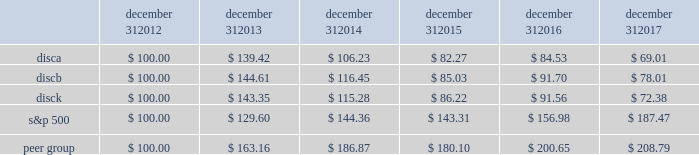Part ii item 5 .
Market for registrant 2019s common equity , related stockholder matters and issuer purchases of equity securities .
Our series a common stock , series b common stock and series c common stock are listed and traded on the nasdaq global select market ( 201cnasdaq 201d ) under the symbols 201cdisca , 201d 201cdiscb 201d and 201cdisck , 201d respectively .
The table sets forth , for the periods indicated , the range of high and low sales prices per share of our series a common stock , series b common stock and series c common stock as reported on yahoo! finance ( finance.yahoo.com ) .
Series a common stock series b common stock series c common stock high low high low high low fourth quarter $ 23.73 $ 16.28 $ 26.80 $ 20.00 $ 22.47 $ 15.27 third quarter $ 27.18 $ 20.80 $ 27.90 $ 22.00 $ 26.21 $ 19.62 second quarter $ 29.40 $ 25.11 $ 29.55 $ 25.45 $ 28.90 $ 24.39 first quarter $ 29.62 $ 26.34 $ 29.65 $ 27.55 $ 28.87 $ 25.76 fourth quarter $ 29.55 $ 25.01 $ 30.50 $ 26.00 $ 28.66 $ 24.20 third quarter $ 26.97 $ 24.27 $ 28.00 $ 25.21 $ 26.31 $ 23.44 second quarter $ 29.31 $ 23.73 $ 29.34 $ 24.15 $ 28.48 $ 22.54 first quarter $ 29.42 $ 24.33 $ 29.34 $ 24.30 $ 28.00 $ 23.81 as of february 21 , 2018 , there were approximately 1308 , 75 and 1414 record holders of our series a common stock , series b common stock and series c common stock , respectively .
These amounts do not include the number of shareholders whose shares are held of record by banks , brokerage houses or other institutions , but include each such institution as one shareholder .
We have not paid any cash dividends on our series a common stock , series b common stock or series c common stock , and we have no present intention to do so .
Payment of cash dividends , if any , will be determined by our board of directors after consideration of our earnings , financial condition and other relevant factors such as our credit facility's restrictions on our ability to declare dividends in certain situations .
Purchases of equity securities the table presents information about our repurchases of common stock that were made through open market transactions during the three months ended december 31 , 2017 ( in millions , except per share amounts ) .
Period total number of series c shares purchased average paid per share : series c ( a ) total number of shares purchased as part of publicly announced plans or programs ( b ) ( c ) approximate dollar value of shares that may yet be purchased under the plans or programs ( a ) ( b ) october 1 , 2017 - october 31 , 2017 2014 $ 2014 2014 $ 2014 november 1 , 2017 - november 30 , 2017 2014 $ 2014 2014 $ 2014 december 1 , 2017 - december 31 , 2017 2014 $ 2014 2014 $ 2014 total 2014 2014 $ 2014 ( a ) the amounts do not give effect to any fees , commissions or other costs associated with repurchases of shares .
( b ) under the stock repurchase program , management was authorized to purchase shares of the company's common stock from time to time through open market purchases or privately negotiated transactions at prevailing prices or pursuant to one or more accelerated stock repurchase agreements or other derivative arrangements as permitted by securities laws and other legal requirements , and subject to stock price , business and market conditions and other factors .
The company's authorization under the program expired on october 8 , 2017 and we have not repurchased any shares of common stock since then .
We historically have funded and in the future may fund stock repurchases through a combination of cash on hand and cash generated by operations and the issuance of debt .
In the future , if further authorization is provided , we may also choose to fund stock repurchases through borrowings under our revolving credit facility or future financing transactions .
There were no repurchases of our series a and b common stock during 2017 and no repurchases of series c common stock during the three months ended december 31 , 2017 .
The company first announced its stock repurchase program on august 3 , 2010 .
( c ) we entered into an agreement with advance/newhouse to repurchase , on a quarterly basis , a number of shares of series c-1 convertible preferred stock convertible into a number of shares of series c common stock .
We did not convert any any shares of series c-1 convertible preferred stock during the three months ended december 31 , 2017 .
There are no planned repurchases of series c-1 convertible preferred stock for the first quarter of 2018 as there were no repurchases of series a or series c common stock during the three months ended december 31 , 2017 .
Stock performance graph the following graph sets forth the cumulative total shareholder return on our series a common stock , series b common stock and series c common stock as compared with the cumulative total return of the companies listed in the standard and poor 2019s 500 stock index ( 201cs&p 500 index 201d ) and a peer group of companies comprised of cbs corporation class b common stock , scripps network interactive , inc. , time warner , inc. , twenty-first century fox , inc .
Class a common stock ( news corporation class a common stock prior to june 2013 ) , viacom , inc .
Class b common stock and the walt disney company .
The graph assumes $ 100 originally invested on december 31 , 2012 in each of our series a common stock , series b common stock and series c common stock , the s&p 500 index , and the stock of our peer group companies , including reinvestment of dividends , for the years ended december 31 , 2013 , 2014 , 2015 , 2016 and 2017 .
December 31 , december 31 , december 31 , december 31 , december 31 , december 31 .

What was the percentage cumulative total shareholder return on disca common stock for the five year period ended december 31 , 2017? 
Computations: ((69.01 - 100) / 100)
Answer: -0.3099. 